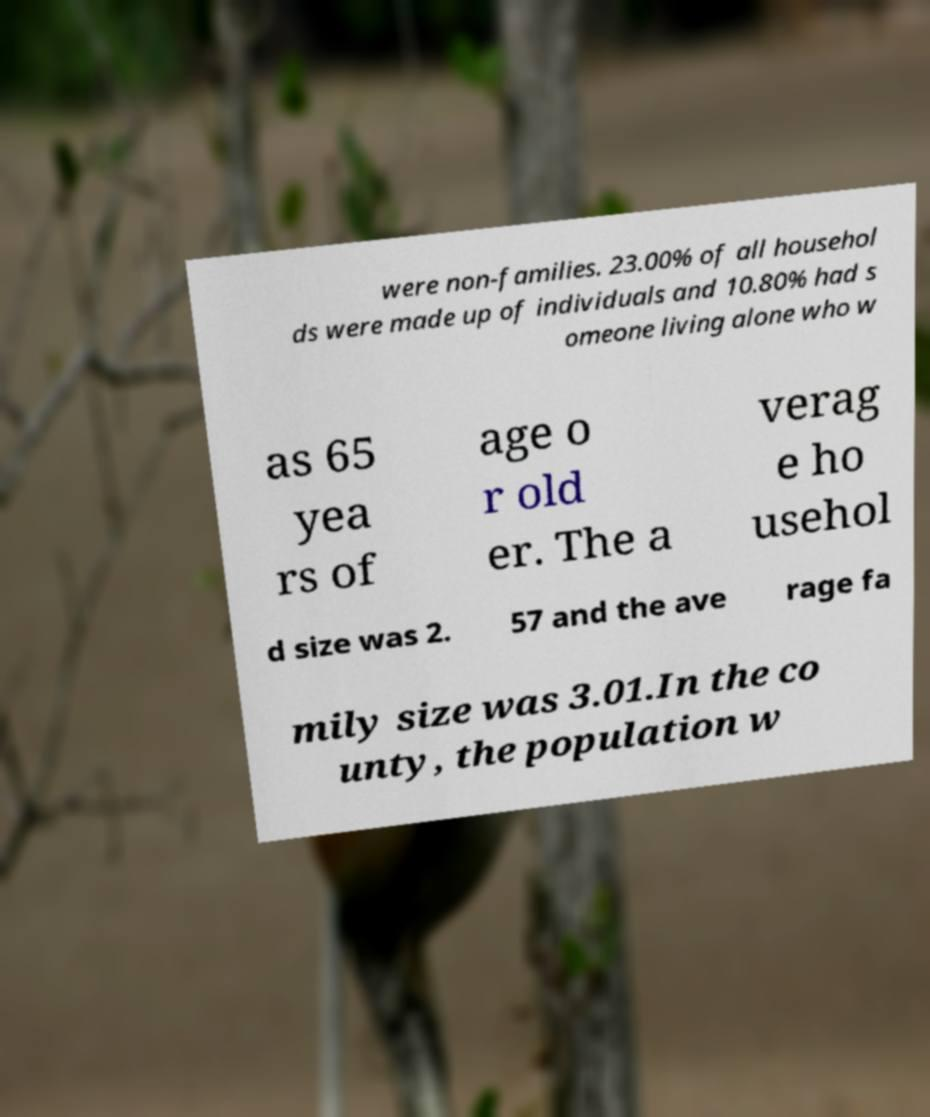Can you accurately transcribe the text from the provided image for me? were non-families. 23.00% of all househol ds were made up of individuals and 10.80% had s omeone living alone who w as 65 yea rs of age o r old er. The a verag e ho usehol d size was 2. 57 and the ave rage fa mily size was 3.01.In the co unty, the population w 